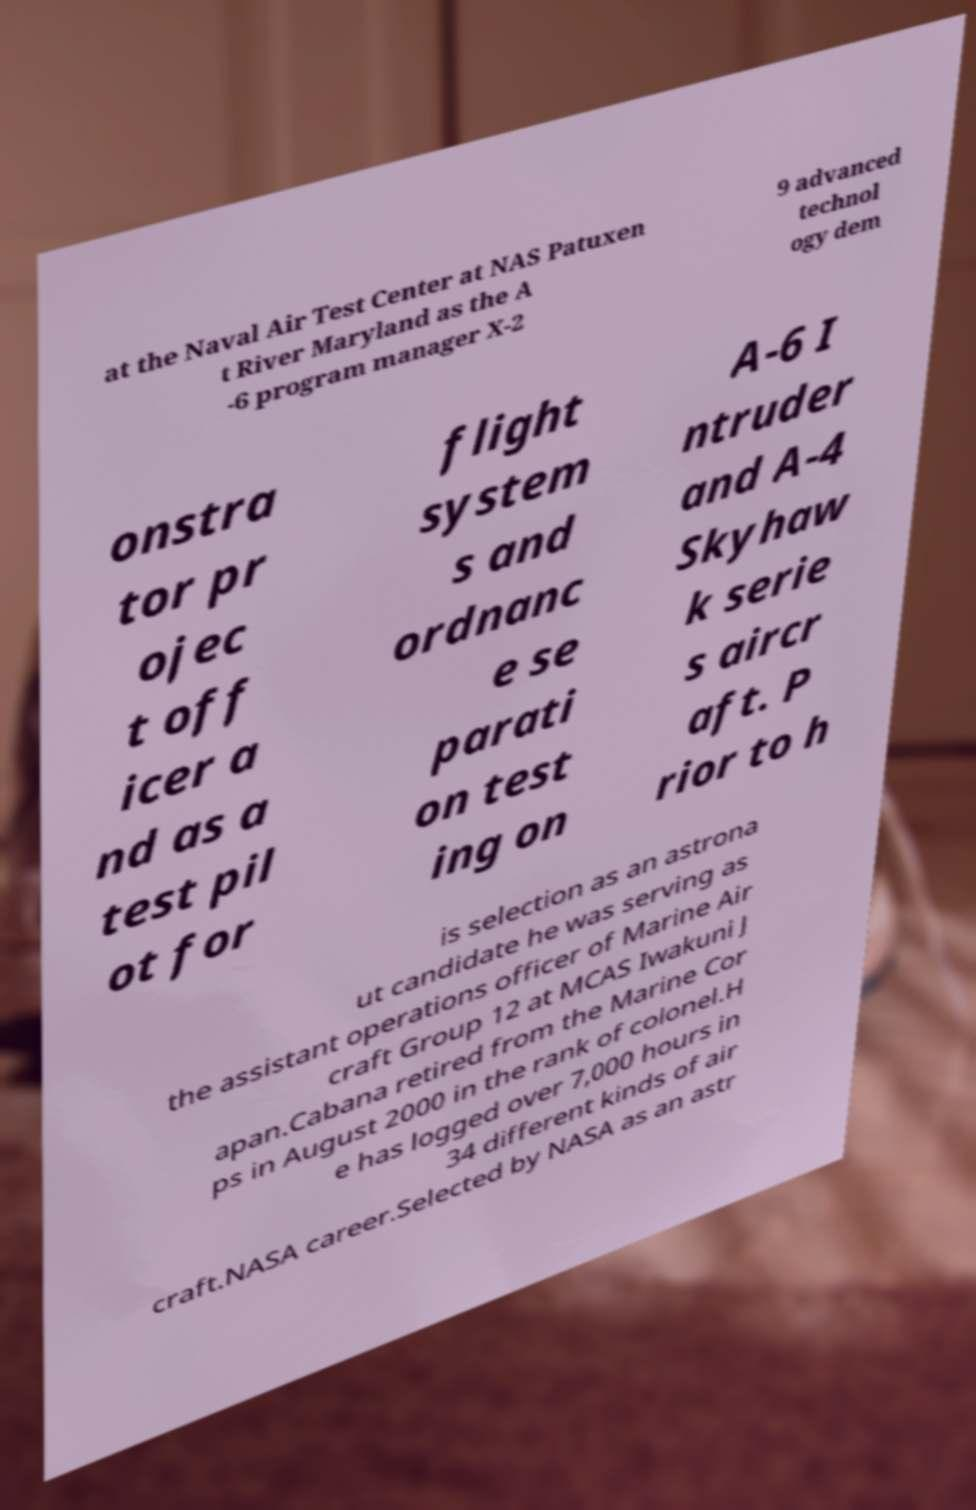Could you extract and type out the text from this image? at the Naval Air Test Center at NAS Patuxen t River Maryland as the A -6 program manager X-2 9 advanced technol ogy dem onstra tor pr ojec t off icer a nd as a test pil ot for flight system s and ordnanc e se parati on test ing on A-6 I ntruder and A-4 Skyhaw k serie s aircr aft. P rior to h is selection as an astrona ut candidate he was serving as the assistant operations officer of Marine Air craft Group 12 at MCAS Iwakuni J apan.Cabana retired from the Marine Cor ps in August 2000 in the rank of colonel.H e has logged over 7,000 hours in 34 different kinds of air craft.NASA career.Selected by NASA as an astr 